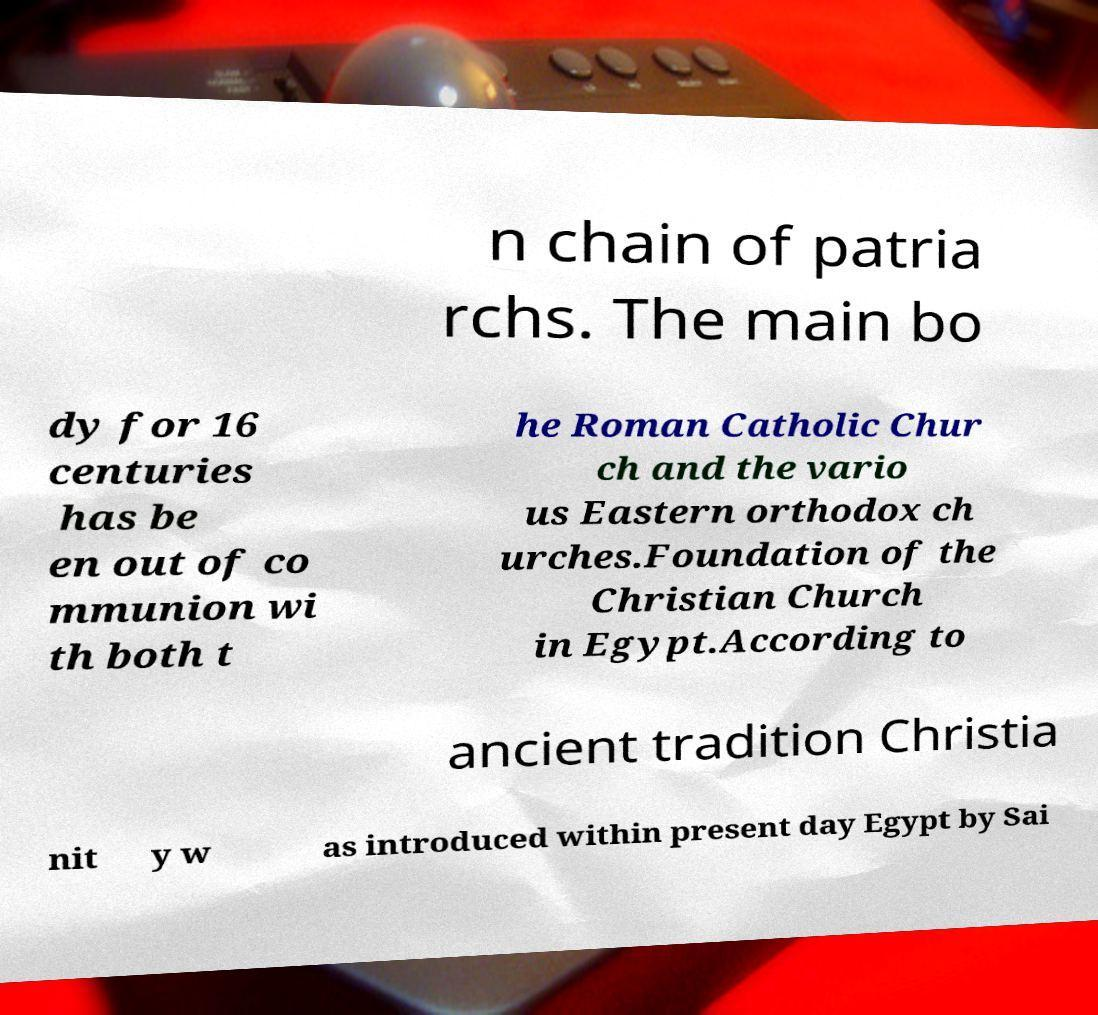Can you accurately transcribe the text from the provided image for me? n chain of patria rchs. The main bo dy for 16 centuries has be en out of co mmunion wi th both t he Roman Catholic Chur ch and the vario us Eastern orthodox ch urches.Foundation of the Christian Church in Egypt.According to ancient tradition Christia nit y w as introduced within present day Egypt by Sai 